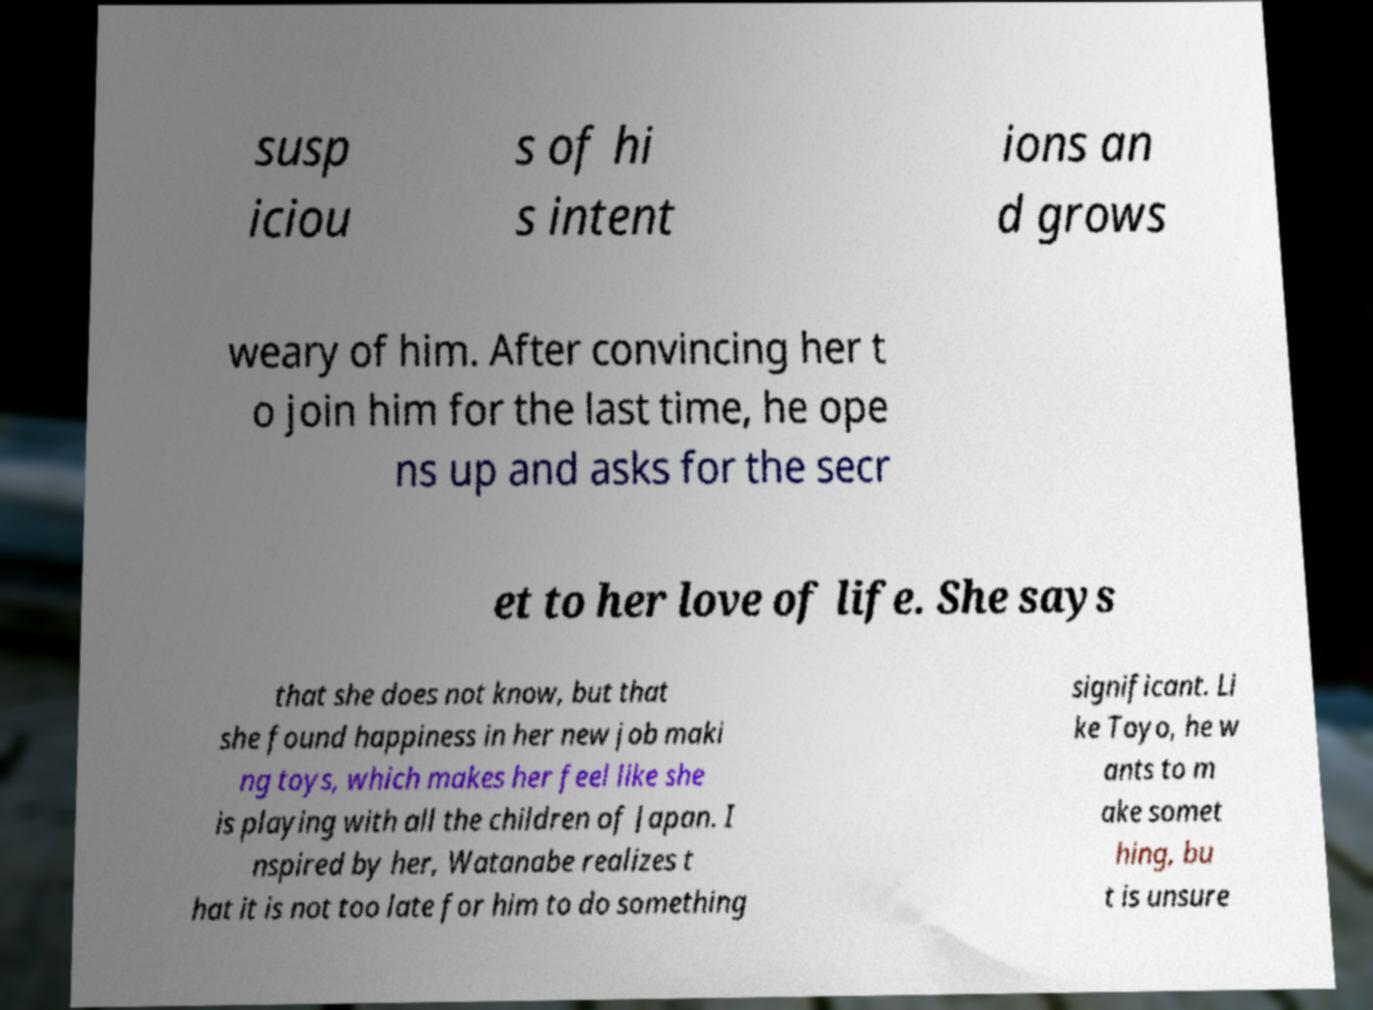Could you assist in decoding the text presented in this image and type it out clearly? susp iciou s of hi s intent ions an d grows weary of him. After convincing her t o join him for the last time, he ope ns up and asks for the secr et to her love of life. She says that she does not know, but that she found happiness in her new job maki ng toys, which makes her feel like she is playing with all the children of Japan. I nspired by her, Watanabe realizes t hat it is not too late for him to do something significant. Li ke Toyo, he w ants to m ake somet hing, bu t is unsure 